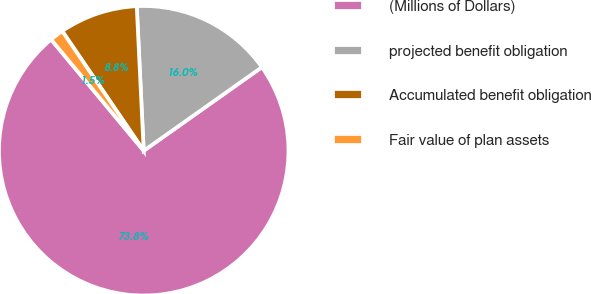Convert chart to OTSL. <chart><loc_0><loc_0><loc_500><loc_500><pie_chart><fcel>(Millions of Dollars)<fcel>projected benefit obligation<fcel>Accumulated benefit obligation<fcel>Fair value of plan assets<nl><fcel>73.75%<fcel>15.97%<fcel>8.75%<fcel>1.53%<nl></chart> 